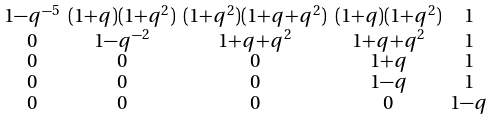Convert formula to latex. <formula><loc_0><loc_0><loc_500><loc_500>\begin{smallmatrix} 1 - q ^ { - 5 } & ( 1 + q ) ( 1 + q ^ { 2 } ) & ( 1 + q ^ { 2 } ) ( 1 + q + q ^ { 2 } ) & ( 1 + q ) ( 1 + q ^ { 2 } ) & 1 \\ 0 & 1 - q ^ { - 2 } & 1 + q + q ^ { 2 } & 1 + q + q ^ { 2 } & 1 \\ 0 & 0 & 0 & 1 + q & 1 \\ 0 & 0 & 0 & 1 - q & 1 \\ 0 & 0 & 0 & 0 & 1 - q \\ \end{smallmatrix}</formula> 